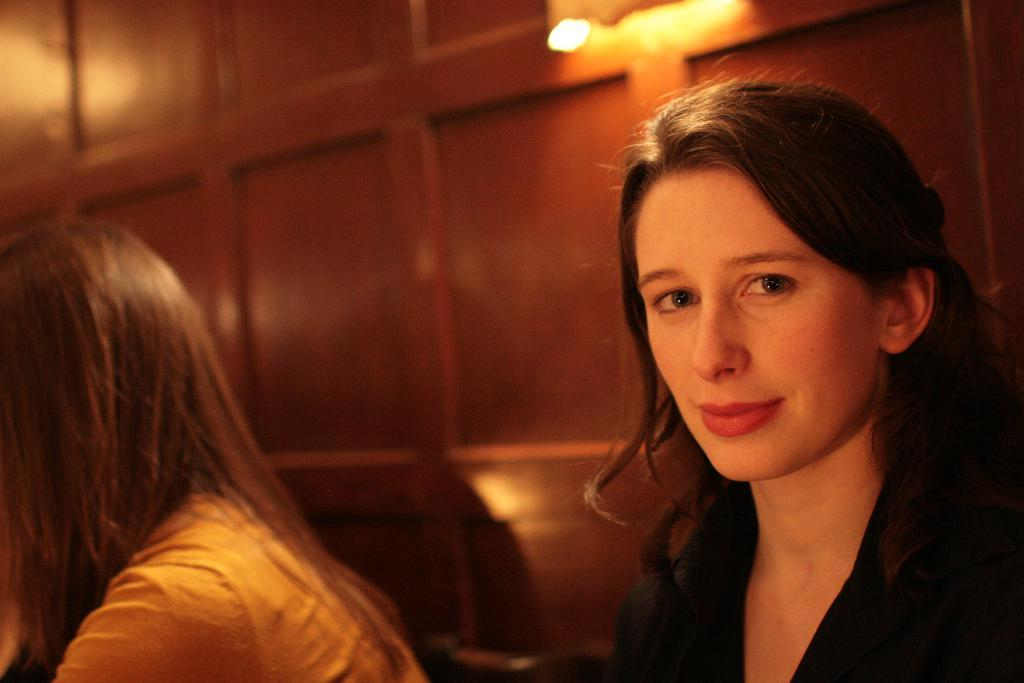How many ladies are present in the image? There are two ladies in the image. Can you describe the background of the image? There is a wooden wall in the background of the image. What type of linen can be seen draped over the wooden wall in the image? There is no linen visible in the image, and the wooden wall is not draped with any fabric. What kind of flower is growing on the wooden wall in the image? There are no flowers present on the wooden wall in the image. 